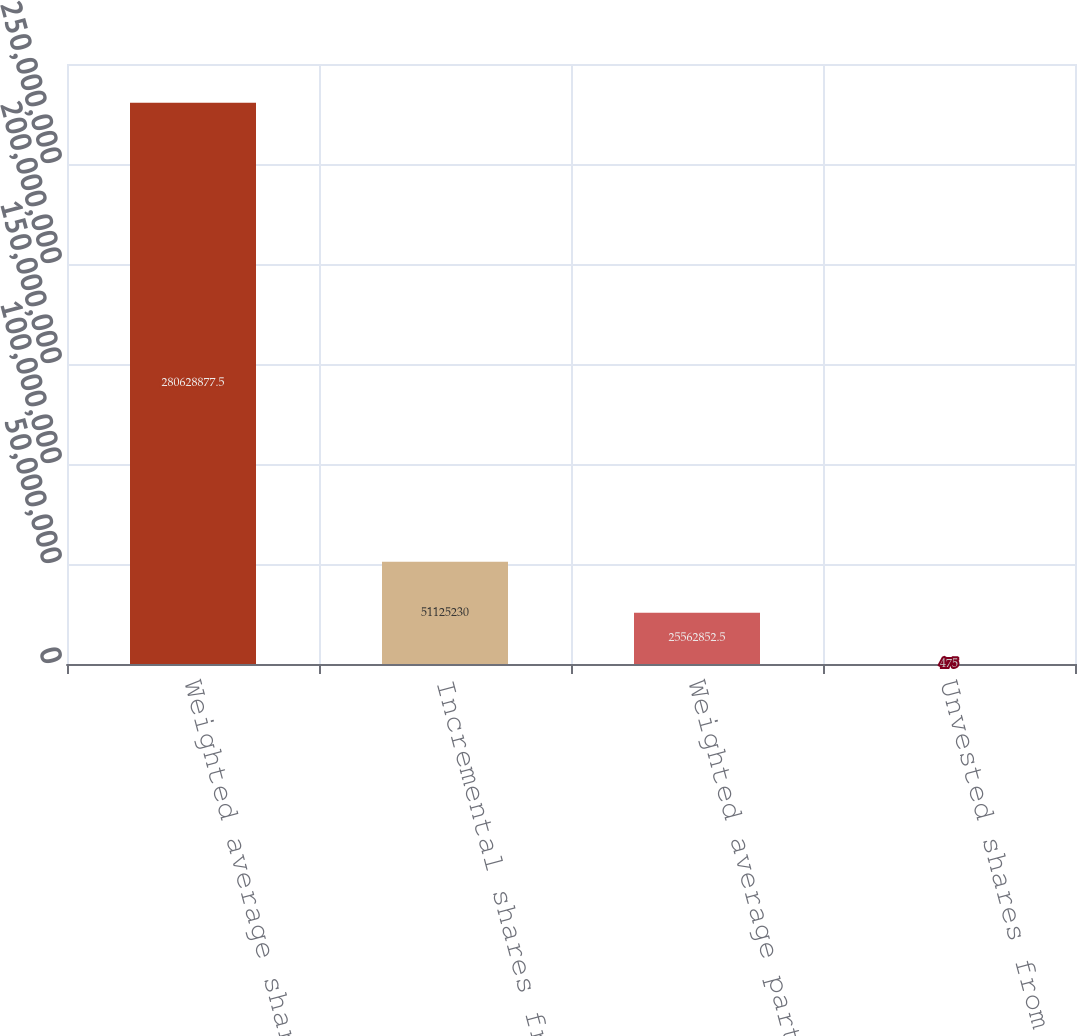Convert chart. <chart><loc_0><loc_0><loc_500><loc_500><bar_chart><fcel>Weighted average shares used<fcel>Incremental shares from<fcel>Weighted average partnership<fcel>Unvested shares from<nl><fcel>2.80629e+08<fcel>5.11252e+07<fcel>2.55629e+07<fcel>475<nl></chart> 